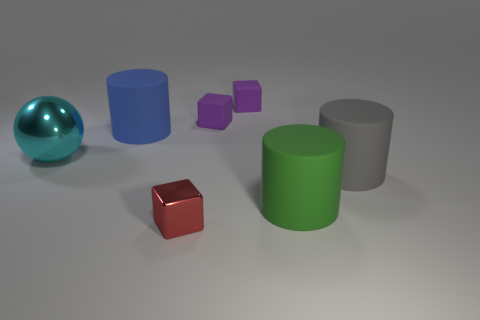Is the number of big gray things that are in front of the large green matte object the same as the number of small brown matte cubes? yes 